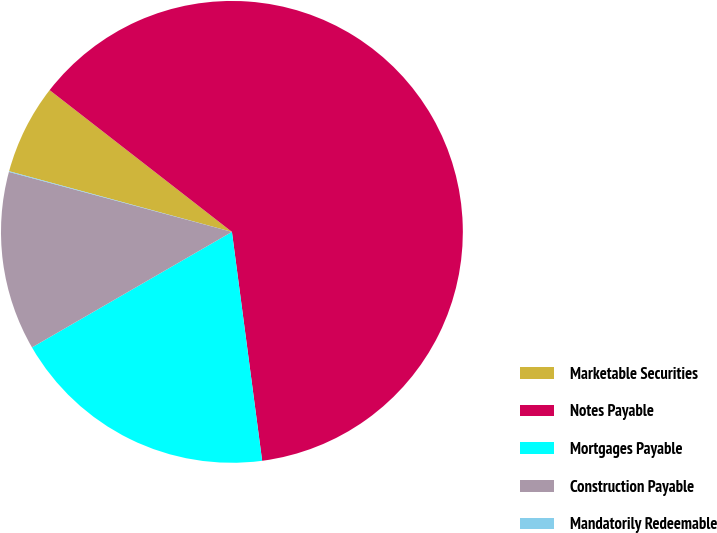<chart> <loc_0><loc_0><loc_500><loc_500><pie_chart><fcel>Marketable Securities<fcel>Notes Payable<fcel>Mortgages Payable<fcel>Construction Payable<fcel>Mandatorily Redeemable<nl><fcel>6.29%<fcel>62.39%<fcel>18.75%<fcel>12.52%<fcel>0.05%<nl></chart> 